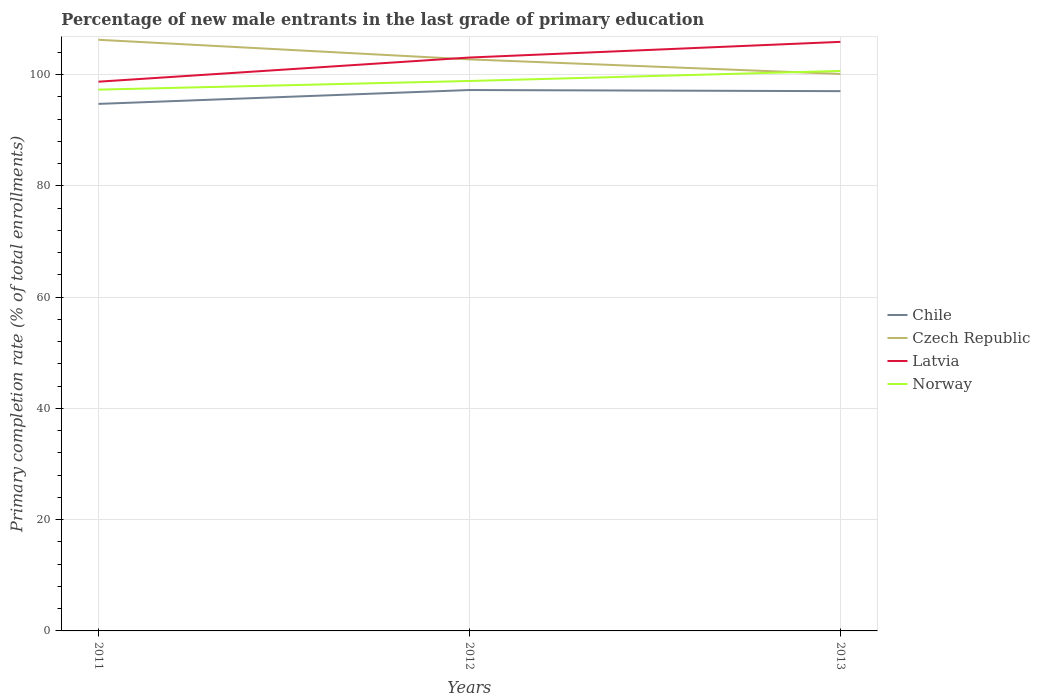How many different coloured lines are there?
Keep it short and to the point. 4. Does the line corresponding to Chile intersect with the line corresponding to Norway?
Your answer should be compact. No. Is the number of lines equal to the number of legend labels?
Give a very brief answer. Yes. Across all years, what is the maximum percentage of new male entrants in Chile?
Give a very brief answer. 94.74. What is the total percentage of new male entrants in Latvia in the graph?
Make the answer very short. -7.16. What is the difference between the highest and the second highest percentage of new male entrants in Latvia?
Make the answer very short. 7.16. What is the difference between the highest and the lowest percentage of new male entrants in Latvia?
Your answer should be compact. 2. How many years are there in the graph?
Your answer should be compact. 3. Are the values on the major ticks of Y-axis written in scientific E-notation?
Offer a very short reply. No. Does the graph contain grids?
Your answer should be compact. Yes. Where does the legend appear in the graph?
Make the answer very short. Center right. How many legend labels are there?
Ensure brevity in your answer.  4. What is the title of the graph?
Provide a short and direct response. Percentage of new male entrants in the last grade of primary education. What is the label or title of the Y-axis?
Give a very brief answer. Primary completion rate (% of total enrollments). What is the Primary completion rate (% of total enrollments) in Chile in 2011?
Provide a succinct answer. 94.74. What is the Primary completion rate (% of total enrollments) in Czech Republic in 2011?
Offer a very short reply. 106.26. What is the Primary completion rate (% of total enrollments) of Latvia in 2011?
Your response must be concise. 98.73. What is the Primary completion rate (% of total enrollments) of Norway in 2011?
Offer a terse response. 97.3. What is the Primary completion rate (% of total enrollments) of Chile in 2012?
Offer a terse response. 97.23. What is the Primary completion rate (% of total enrollments) in Czech Republic in 2012?
Offer a terse response. 102.74. What is the Primary completion rate (% of total enrollments) of Latvia in 2012?
Your answer should be very brief. 103.07. What is the Primary completion rate (% of total enrollments) of Norway in 2012?
Offer a terse response. 98.85. What is the Primary completion rate (% of total enrollments) in Chile in 2013?
Provide a short and direct response. 97.03. What is the Primary completion rate (% of total enrollments) in Czech Republic in 2013?
Ensure brevity in your answer.  100.13. What is the Primary completion rate (% of total enrollments) in Latvia in 2013?
Your response must be concise. 105.89. What is the Primary completion rate (% of total enrollments) of Norway in 2013?
Your answer should be compact. 100.66. Across all years, what is the maximum Primary completion rate (% of total enrollments) of Chile?
Keep it short and to the point. 97.23. Across all years, what is the maximum Primary completion rate (% of total enrollments) in Czech Republic?
Ensure brevity in your answer.  106.26. Across all years, what is the maximum Primary completion rate (% of total enrollments) of Latvia?
Ensure brevity in your answer.  105.89. Across all years, what is the maximum Primary completion rate (% of total enrollments) in Norway?
Your answer should be very brief. 100.66. Across all years, what is the minimum Primary completion rate (% of total enrollments) of Chile?
Your response must be concise. 94.74. Across all years, what is the minimum Primary completion rate (% of total enrollments) in Czech Republic?
Provide a succinct answer. 100.13. Across all years, what is the minimum Primary completion rate (% of total enrollments) in Latvia?
Give a very brief answer. 98.73. Across all years, what is the minimum Primary completion rate (% of total enrollments) of Norway?
Offer a terse response. 97.3. What is the total Primary completion rate (% of total enrollments) of Chile in the graph?
Your answer should be very brief. 289. What is the total Primary completion rate (% of total enrollments) of Czech Republic in the graph?
Keep it short and to the point. 309.13. What is the total Primary completion rate (% of total enrollments) of Latvia in the graph?
Keep it short and to the point. 307.69. What is the total Primary completion rate (% of total enrollments) in Norway in the graph?
Keep it short and to the point. 296.82. What is the difference between the Primary completion rate (% of total enrollments) in Chile in 2011 and that in 2012?
Your answer should be very brief. -2.49. What is the difference between the Primary completion rate (% of total enrollments) in Czech Republic in 2011 and that in 2012?
Your response must be concise. 3.52. What is the difference between the Primary completion rate (% of total enrollments) in Latvia in 2011 and that in 2012?
Offer a terse response. -4.34. What is the difference between the Primary completion rate (% of total enrollments) of Norway in 2011 and that in 2012?
Your answer should be compact. -1.55. What is the difference between the Primary completion rate (% of total enrollments) in Chile in 2011 and that in 2013?
Your answer should be very brief. -2.29. What is the difference between the Primary completion rate (% of total enrollments) in Czech Republic in 2011 and that in 2013?
Offer a terse response. 6.14. What is the difference between the Primary completion rate (% of total enrollments) of Latvia in 2011 and that in 2013?
Your response must be concise. -7.16. What is the difference between the Primary completion rate (% of total enrollments) of Norway in 2011 and that in 2013?
Keep it short and to the point. -3.36. What is the difference between the Primary completion rate (% of total enrollments) of Chile in 2012 and that in 2013?
Your response must be concise. 0.2. What is the difference between the Primary completion rate (% of total enrollments) in Czech Republic in 2012 and that in 2013?
Offer a very short reply. 2.62. What is the difference between the Primary completion rate (% of total enrollments) of Latvia in 2012 and that in 2013?
Offer a terse response. -2.82. What is the difference between the Primary completion rate (% of total enrollments) of Norway in 2012 and that in 2013?
Your answer should be compact. -1.81. What is the difference between the Primary completion rate (% of total enrollments) in Chile in 2011 and the Primary completion rate (% of total enrollments) in Czech Republic in 2012?
Offer a terse response. -8. What is the difference between the Primary completion rate (% of total enrollments) in Chile in 2011 and the Primary completion rate (% of total enrollments) in Latvia in 2012?
Your answer should be very brief. -8.34. What is the difference between the Primary completion rate (% of total enrollments) in Chile in 2011 and the Primary completion rate (% of total enrollments) in Norway in 2012?
Offer a terse response. -4.12. What is the difference between the Primary completion rate (% of total enrollments) of Czech Republic in 2011 and the Primary completion rate (% of total enrollments) of Latvia in 2012?
Your answer should be compact. 3.19. What is the difference between the Primary completion rate (% of total enrollments) of Czech Republic in 2011 and the Primary completion rate (% of total enrollments) of Norway in 2012?
Your response must be concise. 7.41. What is the difference between the Primary completion rate (% of total enrollments) of Latvia in 2011 and the Primary completion rate (% of total enrollments) of Norway in 2012?
Offer a very short reply. -0.13. What is the difference between the Primary completion rate (% of total enrollments) of Chile in 2011 and the Primary completion rate (% of total enrollments) of Czech Republic in 2013?
Your answer should be compact. -5.39. What is the difference between the Primary completion rate (% of total enrollments) of Chile in 2011 and the Primary completion rate (% of total enrollments) of Latvia in 2013?
Your answer should be compact. -11.15. What is the difference between the Primary completion rate (% of total enrollments) of Chile in 2011 and the Primary completion rate (% of total enrollments) of Norway in 2013?
Ensure brevity in your answer.  -5.92. What is the difference between the Primary completion rate (% of total enrollments) of Czech Republic in 2011 and the Primary completion rate (% of total enrollments) of Latvia in 2013?
Ensure brevity in your answer.  0.37. What is the difference between the Primary completion rate (% of total enrollments) in Czech Republic in 2011 and the Primary completion rate (% of total enrollments) in Norway in 2013?
Keep it short and to the point. 5.6. What is the difference between the Primary completion rate (% of total enrollments) in Latvia in 2011 and the Primary completion rate (% of total enrollments) in Norway in 2013?
Offer a very short reply. -1.93. What is the difference between the Primary completion rate (% of total enrollments) in Chile in 2012 and the Primary completion rate (% of total enrollments) in Czech Republic in 2013?
Ensure brevity in your answer.  -2.89. What is the difference between the Primary completion rate (% of total enrollments) in Chile in 2012 and the Primary completion rate (% of total enrollments) in Latvia in 2013?
Offer a very short reply. -8.66. What is the difference between the Primary completion rate (% of total enrollments) in Chile in 2012 and the Primary completion rate (% of total enrollments) in Norway in 2013?
Your answer should be very brief. -3.43. What is the difference between the Primary completion rate (% of total enrollments) in Czech Republic in 2012 and the Primary completion rate (% of total enrollments) in Latvia in 2013?
Your answer should be very brief. -3.15. What is the difference between the Primary completion rate (% of total enrollments) of Czech Republic in 2012 and the Primary completion rate (% of total enrollments) of Norway in 2013?
Ensure brevity in your answer.  2.08. What is the difference between the Primary completion rate (% of total enrollments) of Latvia in 2012 and the Primary completion rate (% of total enrollments) of Norway in 2013?
Your answer should be compact. 2.41. What is the average Primary completion rate (% of total enrollments) of Chile per year?
Keep it short and to the point. 96.33. What is the average Primary completion rate (% of total enrollments) in Czech Republic per year?
Provide a succinct answer. 103.04. What is the average Primary completion rate (% of total enrollments) in Latvia per year?
Keep it short and to the point. 102.56. What is the average Primary completion rate (% of total enrollments) of Norway per year?
Give a very brief answer. 98.94. In the year 2011, what is the difference between the Primary completion rate (% of total enrollments) in Chile and Primary completion rate (% of total enrollments) in Czech Republic?
Keep it short and to the point. -11.53. In the year 2011, what is the difference between the Primary completion rate (% of total enrollments) in Chile and Primary completion rate (% of total enrollments) in Latvia?
Your answer should be compact. -3.99. In the year 2011, what is the difference between the Primary completion rate (% of total enrollments) in Chile and Primary completion rate (% of total enrollments) in Norway?
Your answer should be compact. -2.57. In the year 2011, what is the difference between the Primary completion rate (% of total enrollments) of Czech Republic and Primary completion rate (% of total enrollments) of Latvia?
Your answer should be compact. 7.53. In the year 2011, what is the difference between the Primary completion rate (% of total enrollments) in Czech Republic and Primary completion rate (% of total enrollments) in Norway?
Provide a short and direct response. 8.96. In the year 2011, what is the difference between the Primary completion rate (% of total enrollments) in Latvia and Primary completion rate (% of total enrollments) in Norway?
Provide a short and direct response. 1.43. In the year 2012, what is the difference between the Primary completion rate (% of total enrollments) in Chile and Primary completion rate (% of total enrollments) in Czech Republic?
Give a very brief answer. -5.51. In the year 2012, what is the difference between the Primary completion rate (% of total enrollments) in Chile and Primary completion rate (% of total enrollments) in Latvia?
Offer a very short reply. -5.84. In the year 2012, what is the difference between the Primary completion rate (% of total enrollments) in Chile and Primary completion rate (% of total enrollments) in Norway?
Provide a short and direct response. -1.62. In the year 2012, what is the difference between the Primary completion rate (% of total enrollments) of Czech Republic and Primary completion rate (% of total enrollments) of Latvia?
Offer a very short reply. -0.33. In the year 2012, what is the difference between the Primary completion rate (% of total enrollments) in Czech Republic and Primary completion rate (% of total enrollments) in Norway?
Your response must be concise. 3.89. In the year 2012, what is the difference between the Primary completion rate (% of total enrollments) of Latvia and Primary completion rate (% of total enrollments) of Norway?
Offer a terse response. 4.22. In the year 2013, what is the difference between the Primary completion rate (% of total enrollments) in Chile and Primary completion rate (% of total enrollments) in Czech Republic?
Provide a short and direct response. -3.1. In the year 2013, what is the difference between the Primary completion rate (% of total enrollments) of Chile and Primary completion rate (% of total enrollments) of Latvia?
Provide a short and direct response. -8.86. In the year 2013, what is the difference between the Primary completion rate (% of total enrollments) in Chile and Primary completion rate (% of total enrollments) in Norway?
Give a very brief answer. -3.63. In the year 2013, what is the difference between the Primary completion rate (% of total enrollments) of Czech Republic and Primary completion rate (% of total enrollments) of Latvia?
Provide a short and direct response. -5.76. In the year 2013, what is the difference between the Primary completion rate (% of total enrollments) of Czech Republic and Primary completion rate (% of total enrollments) of Norway?
Ensure brevity in your answer.  -0.54. In the year 2013, what is the difference between the Primary completion rate (% of total enrollments) of Latvia and Primary completion rate (% of total enrollments) of Norway?
Provide a succinct answer. 5.23. What is the ratio of the Primary completion rate (% of total enrollments) in Chile in 2011 to that in 2012?
Your response must be concise. 0.97. What is the ratio of the Primary completion rate (% of total enrollments) of Czech Republic in 2011 to that in 2012?
Provide a succinct answer. 1.03. What is the ratio of the Primary completion rate (% of total enrollments) of Latvia in 2011 to that in 2012?
Your answer should be compact. 0.96. What is the ratio of the Primary completion rate (% of total enrollments) of Norway in 2011 to that in 2012?
Keep it short and to the point. 0.98. What is the ratio of the Primary completion rate (% of total enrollments) of Chile in 2011 to that in 2013?
Make the answer very short. 0.98. What is the ratio of the Primary completion rate (% of total enrollments) of Czech Republic in 2011 to that in 2013?
Make the answer very short. 1.06. What is the ratio of the Primary completion rate (% of total enrollments) in Latvia in 2011 to that in 2013?
Give a very brief answer. 0.93. What is the ratio of the Primary completion rate (% of total enrollments) in Norway in 2011 to that in 2013?
Give a very brief answer. 0.97. What is the ratio of the Primary completion rate (% of total enrollments) in Chile in 2012 to that in 2013?
Keep it short and to the point. 1. What is the ratio of the Primary completion rate (% of total enrollments) in Czech Republic in 2012 to that in 2013?
Keep it short and to the point. 1.03. What is the ratio of the Primary completion rate (% of total enrollments) of Latvia in 2012 to that in 2013?
Your response must be concise. 0.97. What is the ratio of the Primary completion rate (% of total enrollments) in Norway in 2012 to that in 2013?
Your answer should be very brief. 0.98. What is the difference between the highest and the second highest Primary completion rate (% of total enrollments) of Chile?
Offer a terse response. 0.2. What is the difference between the highest and the second highest Primary completion rate (% of total enrollments) in Czech Republic?
Make the answer very short. 3.52. What is the difference between the highest and the second highest Primary completion rate (% of total enrollments) in Latvia?
Provide a succinct answer. 2.82. What is the difference between the highest and the second highest Primary completion rate (% of total enrollments) in Norway?
Offer a terse response. 1.81. What is the difference between the highest and the lowest Primary completion rate (% of total enrollments) in Chile?
Ensure brevity in your answer.  2.49. What is the difference between the highest and the lowest Primary completion rate (% of total enrollments) of Czech Republic?
Offer a very short reply. 6.14. What is the difference between the highest and the lowest Primary completion rate (% of total enrollments) in Latvia?
Offer a very short reply. 7.16. What is the difference between the highest and the lowest Primary completion rate (% of total enrollments) of Norway?
Offer a terse response. 3.36. 